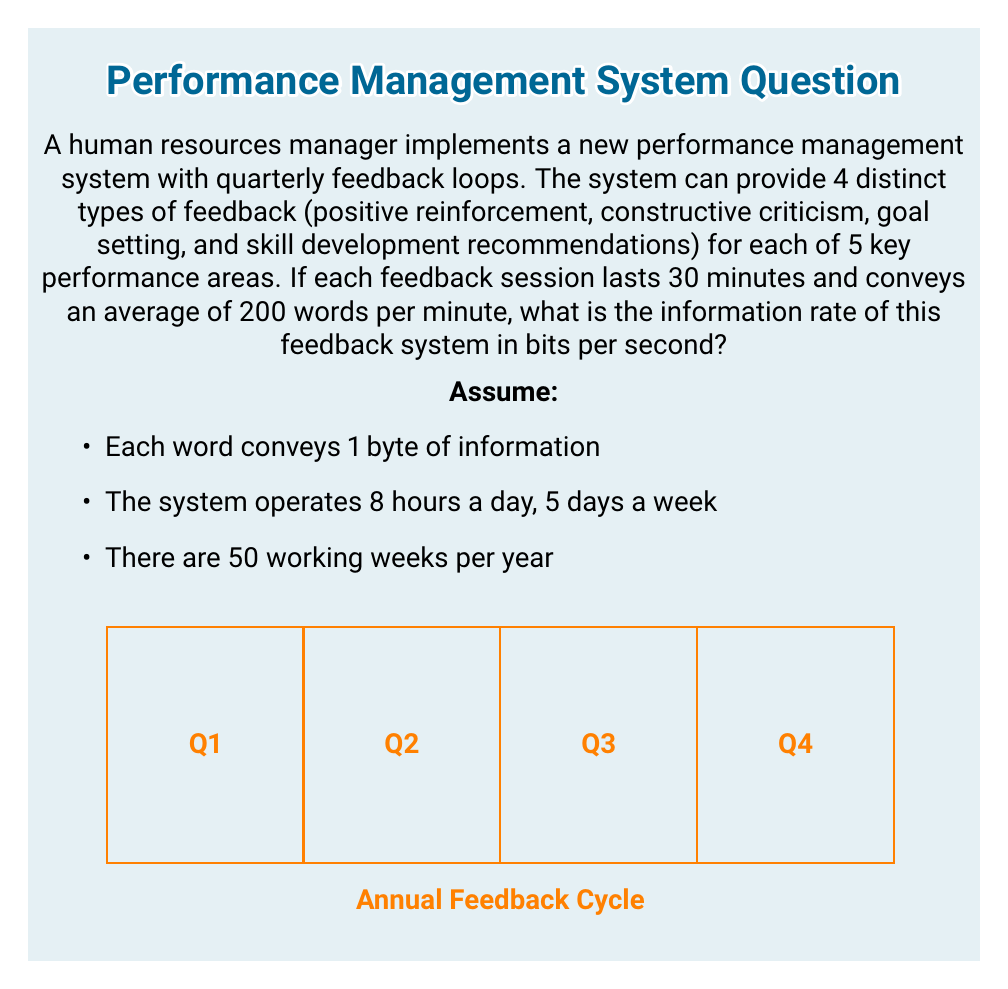Provide a solution to this math problem. Let's approach this step-by-step:

1) First, calculate the number of possible feedback combinations:
   $$4 \text{ types} \times 5 \text{ areas} = 20 \text{ combinations}$$

2) Calculate the information content of each feedback session:
   $$\log_2(20) \approx 4.32 \text{ bits per feedback}$$

3) Calculate the amount of information conveyed in words per feedback session:
   $$30 \text{ minutes} \times 200 \text{ words/minute} = 6000 \text{ words}$$
   $$6000 \text{ words} \times 8 \text{ bits/word} = 48000 \text{ bits}$$

4) Calculate the number of feedback sessions per year:
   $$4 \text{ quarters} \times 50 \text{ weeks} = 200 \text{ sessions/year}$$

5) Calculate the total information conveyed per year:
   $$200 \text{ sessions} \times 48000 \text{ bits/session} = 9600000 \text{ bits/year}$$

6) Calculate the number of working seconds per year:
   $$8 \text{ hours/day} \times 3600 \text{ seconds/hour} \times 5 \text{ days/week} \times 50 \text{ weeks/year} = 7200000 \text{ seconds/year}$$

7) Calculate the information rate:
   $$\frac{9600000 \text{ bits/year}}{7200000 \text{ seconds/year}} = \frac{4}{3} \text{ bits/second}$$
Answer: $\frac{4}{3}$ bits/second 